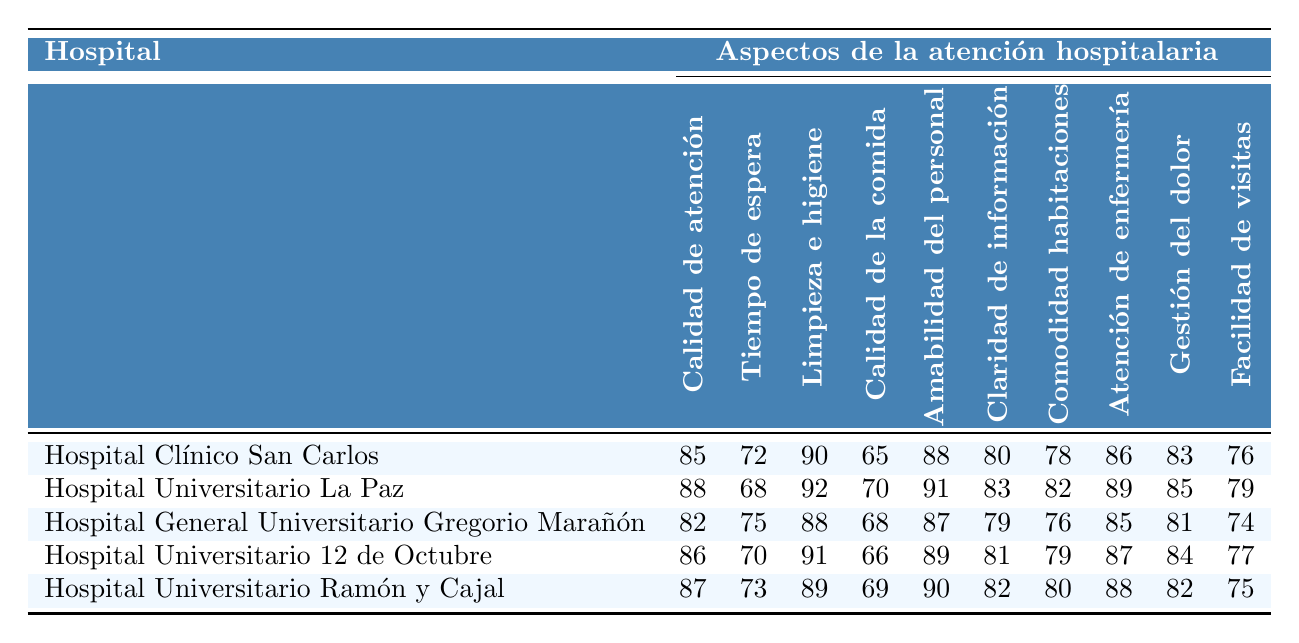¿Cuál hospital tiene la mejor tasa de satisfacción en calidad de atención médica? Comparando las tasas de satisfacción en calidad de atención médica en la tabla, el Hospital Universitario La Paz tiene la mayor calificación con 88.
Answer: Hospital Universitario La Paz ¿Cuál es la tasa de satisfacción más alta en limpieza e higiene? Observando la columna de limpieza e higiene, el Hospital Universitario La Paz tiene la mejor calificación con 92.
Answer: 92 ¿Hay algún hospital que tenga una calificación de 70 o más en calidad de la comida? Revisando la columna de calidad de la comida, el Hospital Universitario La Paz (70), Hospital General Universitario Gregorio Marañón (68) y Hospital Universitario Ramón y Cajal (69) tienen calificaciones de 70 o más.
Answer: Sí ¿En qué hospital es menor la tasa de satisfacción en tiempo de espera? Al observar la columna de tiempo de espera, el Hospital Universitario La Paz tiene la mejor calificación con 68, lo que indica que tiene el menor tiempo de espera.
Answer: Hospital Universitario La Paz ¿Cuál es el promedio de satisfacción en la claridad de la información de todos los hospitales? Sumando las calificaciones de claridad de la información (80 + 83 + 79 + 81 + 82) = 405 y luego dividiendo por el número de hospitales (405/5) se obtiene un promedio de 81.
Answer: 81 Comparando la amabilidad del personal, ¿cuál hospital destaca más y cómo se relaciona con la calidad de atención médica? La calificación más alta en amabilidad del personal es del Hospital Universitario Ramón y Cajal (90), que tiene una calificación de calidad de atención médica de 87. Ambos son altos, pero el Hospital Universitario La Paz tiene la mejor calidad de atención médica (88) aunque con una amabilidad del personal ligeramente inferior (91).
Answer: Hospital Universitario Ramón y Cajal ¿Cuál hospital tiene la peor tasa de satisfacción en gestión del dolor y cuál es su puntuación? La tabla muestra que el Hospital General Universitario Gregorio Marañón tiene la peor calificación en gestión del dolor con un puntaje de 81.
Answer: Hospital General Universitario Gregorio Marañón ¿La tasa de satisfacción en comodidad de las habitaciones es siempre mayor que 75 en todos los hospitales? Revisando la columna de comodidad de las habitaciones, la calificación más baja es 76 en el Hospital General Universitario Gregorio Marañón, que indica que no todos los hospitales tienen una calificación mayor a 75.
Answer: No ¿Cuál es la diferencia en la tasa de satisfacción entre el hospital con la mejor calidad de atención y el que tiene la menor? La calificación más alta en calidad de atención es 88 (Hospital Universitario La Paz) y la más baja es 82 (Hospital General Universitario Gregorio Marañón). La diferencia es 88 - 82 = 6.
Answer: 6 ¿Qué hospital tiene la mejor satisfacción en limpieza e higiene y cuáles son las puntuaciones de los hospitales en esta categoría? El Hospital Universitario La Paz tiene la mejor puntuación en limpieza e higiene con 92, seguido de Hospital Clínico San Carlos (90), Hospital Universitario 12 de Octubre (91), Hospital General Universitario Gregorio Marañón (88), y Hospital Universitario Ramón y Cajal (89).
Answer: Hospital Universitario La Paz ¿Cuál hospital tiene la menor tasa de satisfacción en facilidad de visitas y cómo se compara con el resto? El hospital con la menor satisfacción en facilidad de visitas es Hospital General Universitario Gregorio Marañón con 74, que es menor que los otros hospitales. Las puntuaciones de los demás son 76 (Hospital Clínico San Carlos), 79 (Hospital Universitario La Paz), 77 (Hospital Universitario 12 de Octubre), y 75 (Hospital Universitario Ramón y Cajal).
Answer: Hospital General Universitario Gregorio Marañón 